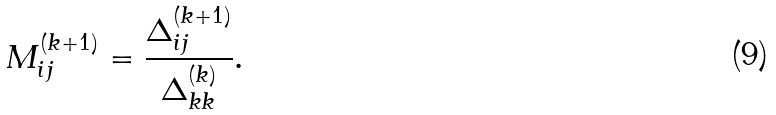Convert formula to latex. <formula><loc_0><loc_0><loc_500><loc_500>M _ { i j } ^ { ( k + 1 ) } = \frac { \Delta _ { i j } ^ { ( k + 1 ) } } { \Delta _ { k k } ^ { ( k ) } } .</formula> 